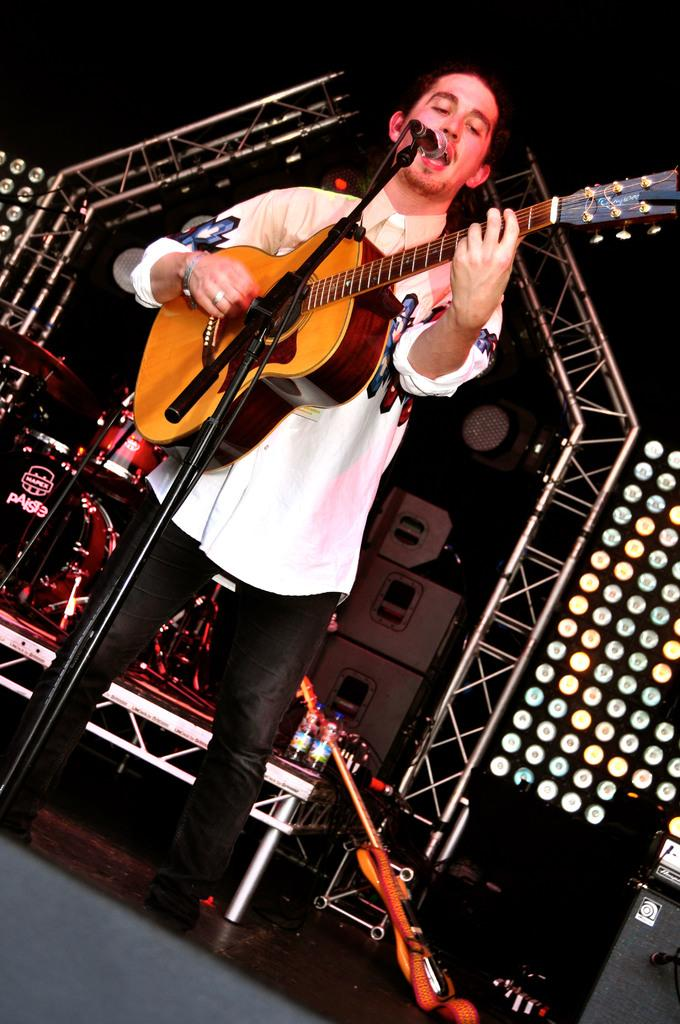What is the person in the image doing? The person is standing in the image and holding a guitar. What object is in front of the person? There is a microphone in front of the person. What can be seen in the background of the image? There are musical instruments and lights in the background of the image. What type of tree can be seen in the background of the image? There is no tree visible in the background of the image. What time of day is it in the image, considering the afternoon? The time of day cannot be determined from the image alone, as there is no indication of the time. 